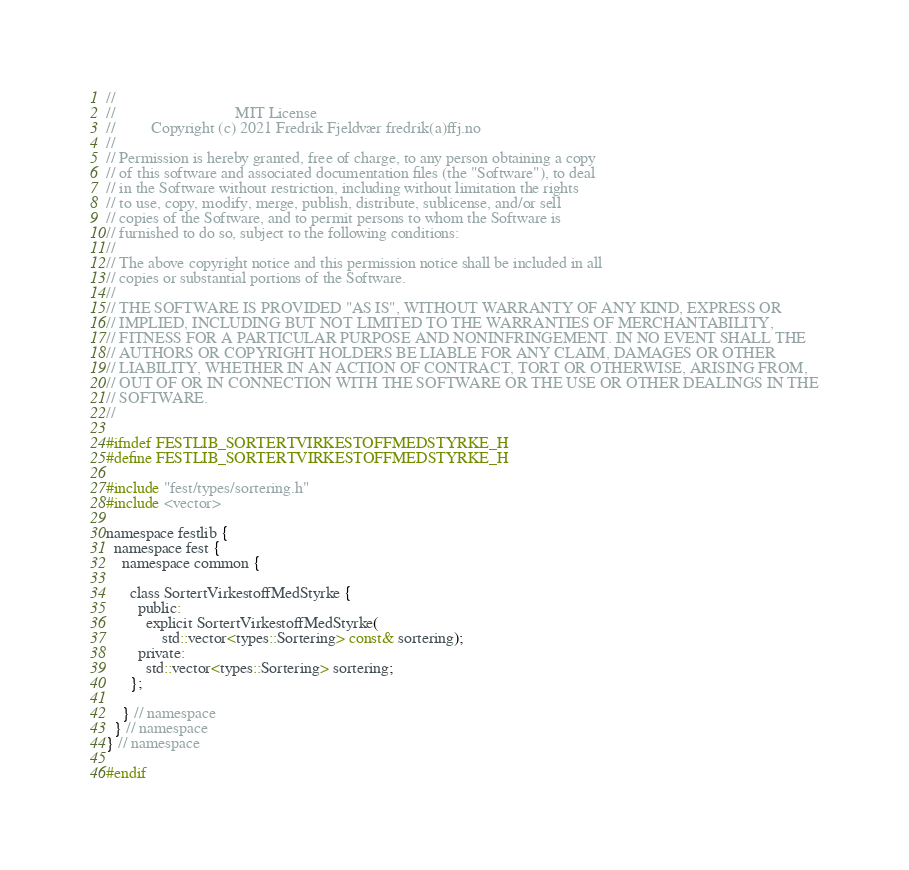<code> <loc_0><loc_0><loc_500><loc_500><_C_>//
//                              MIT License
//         Copyright (c) 2021 Fredrik Fjeldvær fredrik(a)ffj.no
//
// Permission is hereby granted, free of charge, to any person obtaining a copy
// of this software and associated documentation files (the "Software"), to deal
// in the Software without restriction, including without limitation the rights
// to use, copy, modify, merge, publish, distribute, sublicense, and/or sell
// copies of the Software, and to permit persons to whom the Software is
// furnished to do so, subject to the following conditions:
//
// The above copyright notice and this permission notice shall be included in all
// copies or substantial portions of the Software.
//
// THE SOFTWARE IS PROVIDED "AS IS", WITHOUT WARRANTY OF ANY KIND, EXPRESS OR
// IMPLIED, INCLUDING BUT NOT LIMITED TO THE WARRANTIES OF MERCHANTABILITY,
// FITNESS FOR A PARTICULAR PURPOSE AND NONINFRINGEMENT. IN NO EVENT SHALL THE
// AUTHORS OR COPYRIGHT HOLDERS BE LIABLE FOR ANY CLAIM, DAMAGES OR OTHER
// LIABILITY, WHETHER IN AN ACTION OF CONTRACT, TORT OR OTHERWISE, ARISING FROM,
// OUT OF OR IN CONNECTION WITH THE SOFTWARE OR THE USE OR OTHER DEALINGS IN THE
// SOFTWARE.
//

#ifndef FESTLIB_SORTERTVIRKESTOFFMEDSTYRKE_H
#define FESTLIB_SORTERTVIRKESTOFFMEDSTYRKE_H

#include "fest/types/sortering.h"
#include <vector>

namespace festlib {
  namespace fest {
    namespace common {

      class SortertVirkestoffMedStyrke {
        public:
          explicit SortertVirkestoffMedStyrke(
              std::vector<types::Sortering> const& sortering);
        private:
          std::vector<types::Sortering> sortering;
      };

    } // namespace
  } // namespace
} // namespace

#endif
</code> 